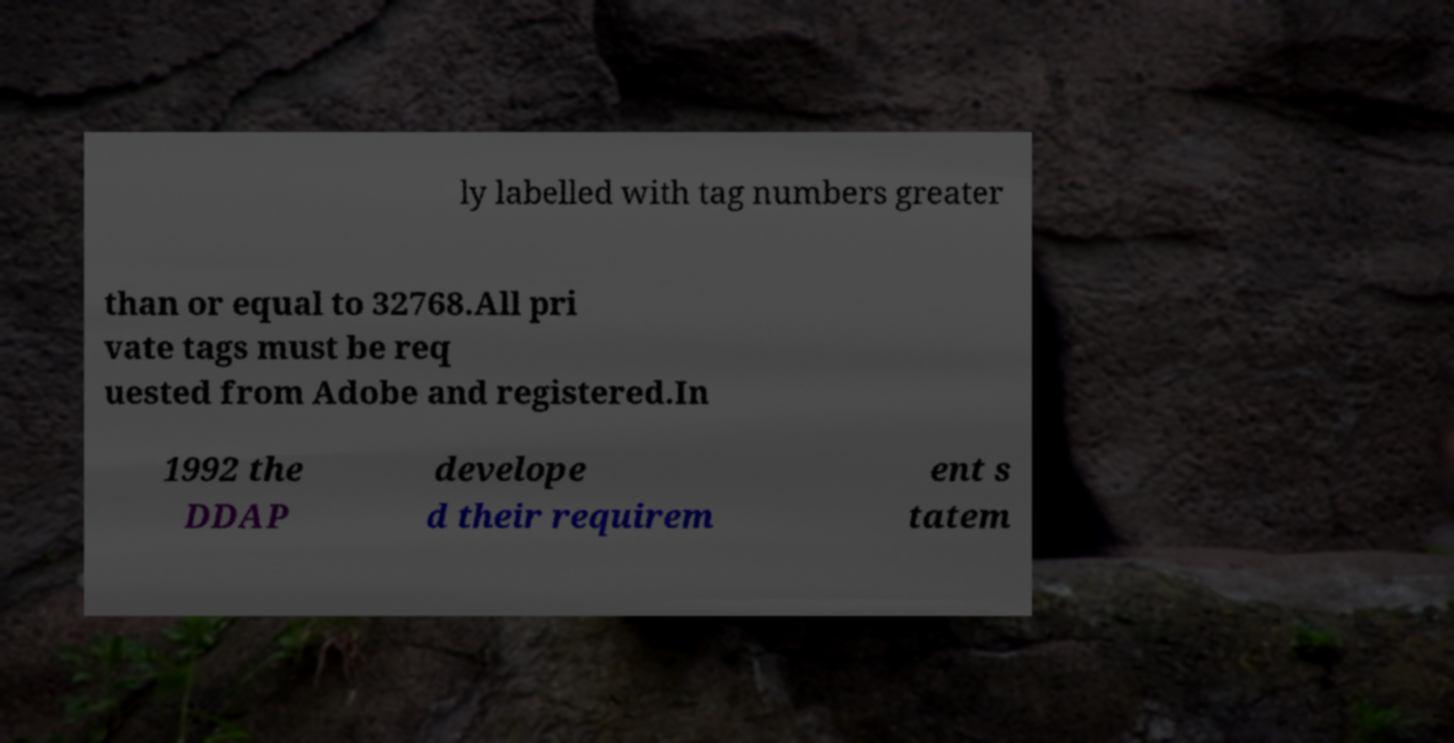What messages or text are displayed in this image? I need them in a readable, typed format. ly labelled with tag numbers greater than or equal to 32768.All pri vate tags must be req uested from Adobe and registered.In 1992 the DDAP develope d their requirem ent s tatem 